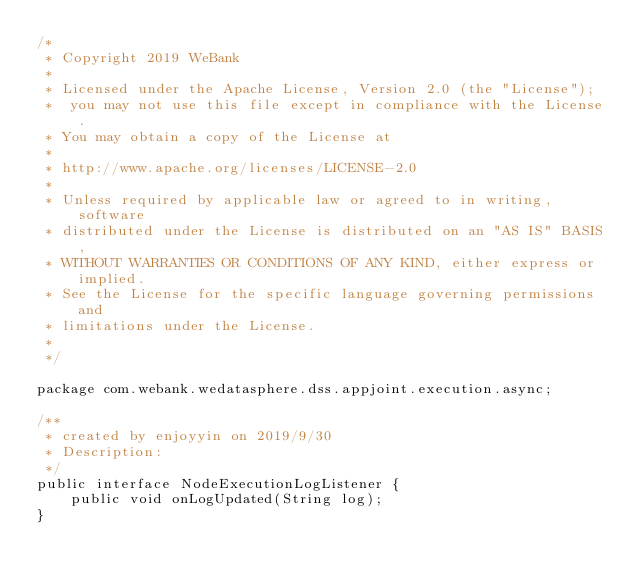Convert code to text. <code><loc_0><loc_0><loc_500><loc_500><_Java_>/*
 * Copyright 2019 WeBank
 *
 * Licensed under the Apache License, Version 2.0 (the "License");
 *  you may not use this file except in compliance with the License.
 * You may obtain a copy of the License at
 *
 * http://www.apache.org/licenses/LICENSE-2.0
 *
 * Unless required by applicable law or agreed to in writing, software
 * distributed under the License is distributed on an "AS IS" BASIS,
 * WITHOUT WARRANTIES OR CONDITIONS OF ANY KIND, either express or implied.
 * See the License for the specific language governing permissions and
 * limitations under the License.
 *
 */

package com.webank.wedatasphere.dss.appjoint.execution.async;

/**
 * created by enjoyyin on 2019/9/30
 * Description:
 */
public interface NodeExecutionLogListener {
    public void onLogUpdated(String log);
}
</code> 